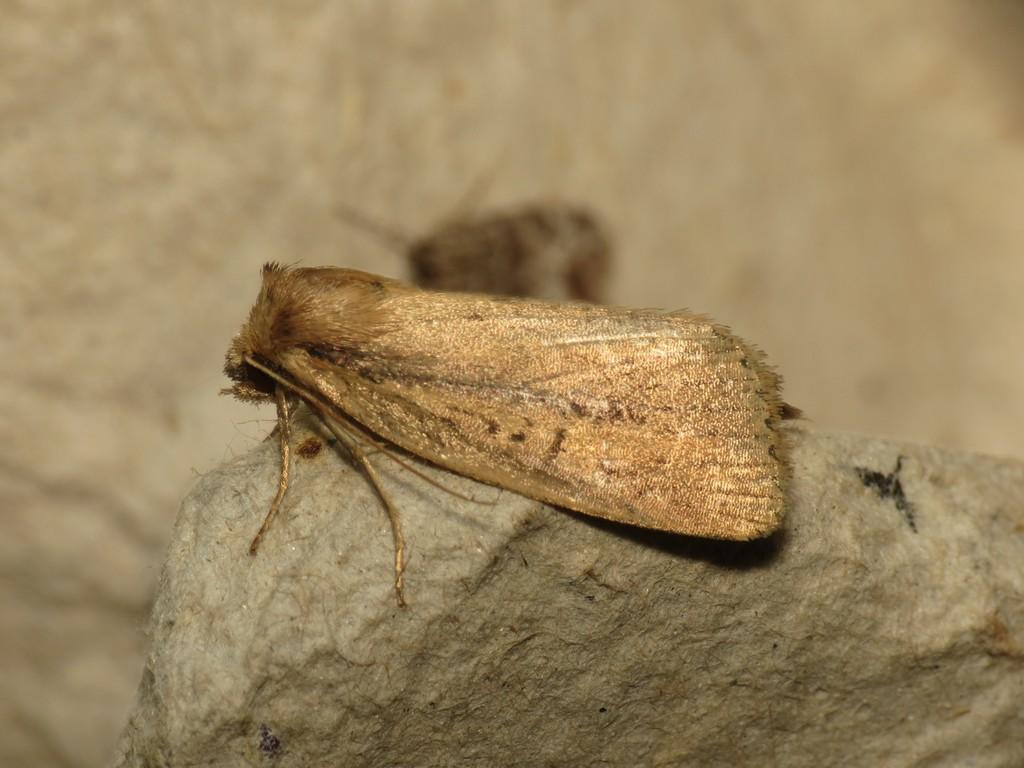What is present in the image? There is an insect in the image. Where is the insect located? The insect is on a rock. Can you describe the background of the rock? The background of the rock is blurred. What type of pan is visible in the image? There is no pan present in the image. Is the turkey visible in the image? There is no turkey present in the image. 